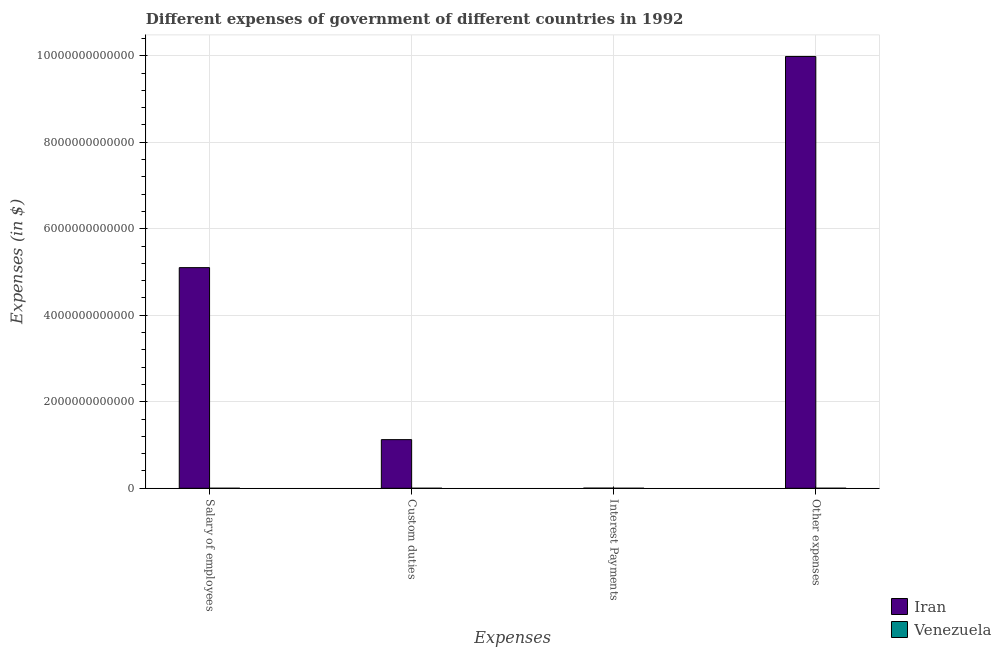How many groups of bars are there?
Your response must be concise. 4. What is the label of the 2nd group of bars from the left?
Your answer should be very brief. Custom duties. What is the amount spent on custom duties in Iran?
Provide a short and direct response. 1.12e+12. Across all countries, what is the maximum amount spent on other expenses?
Your answer should be very brief. 9.98e+12. Across all countries, what is the minimum amount spent on custom duties?
Your answer should be very brief. 8.47e+07. In which country was the amount spent on other expenses maximum?
Make the answer very short. Iran. In which country was the amount spent on interest payments minimum?
Provide a succinct answer. Venezuela. What is the total amount spent on interest payments in the graph?
Provide a succinct answer. 3.13e+09. What is the difference between the amount spent on other expenses in Venezuela and that in Iran?
Provide a short and direct response. -9.98e+12. What is the difference between the amount spent on custom duties in Venezuela and the amount spent on interest payments in Iran?
Make the answer very short. -2.92e+09. What is the average amount spent on custom duties per country?
Ensure brevity in your answer.  5.62e+11. What is the difference between the amount spent on other expenses and amount spent on custom duties in Iran?
Your answer should be compact. 8.86e+12. In how many countries, is the amount spent on other expenses greater than 7600000000000 $?
Provide a succinct answer. 1. What is the ratio of the amount spent on custom duties in Venezuela to that in Iran?
Your response must be concise. 7.528679413072477e-5. Is the amount spent on salary of employees in Iran less than that in Venezuela?
Provide a succinct answer. No. Is the difference between the amount spent on salary of employees in Venezuela and Iran greater than the difference between the amount spent on interest payments in Venezuela and Iran?
Offer a terse response. No. What is the difference between the highest and the second highest amount spent on other expenses?
Keep it short and to the point. 9.98e+12. What is the difference between the highest and the lowest amount spent on custom duties?
Make the answer very short. 1.12e+12. Is it the case that in every country, the sum of the amount spent on other expenses and amount spent on salary of employees is greater than the sum of amount spent on interest payments and amount spent on custom duties?
Give a very brief answer. No. What does the 2nd bar from the left in Custom duties represents?
Ensure brevity in your answer.  Venezuela. What does the 2nd bar from the right in Interest Payments represents?
Offer a very short reply. Iran. Is it the case that in every country, the sum of the amount spent on salary of employees and amount spent on custom duties is greater than the amount spent on interest payments?
Your answer should be compact. Yes. How many bars are there?
Offer a terse response. 8. Are all the bars in the graph horizontal?
Your answer should be compact. No. How many countries are there in the graph?
Offer a very short reply. 2. What is the difference between two consecutive major ticks on the Y-axis?
Your answer should be compact. 2.00e+12. Does the graph contain grids?
Provide a short and direct response. Yes. What is the title of the graph?
Make the answer very short. Different expenses of government of different countries in 1992. What is the label or title of the X-axis?
Your answer should be compact. Expenses. What is the label or title of the Y-axis?
Provide a short and direct response. Expenses (in $). What is the Expenses (in $) in Iran in Salary of employees?
Give a very brief answer. 5.10e+12. What is the Expenses (in $) in Venezuela in Salary of employees?
Ensure brevity in your answer.  2.16e+08. What is the Expenses (in $) in Iran in Custom duties?
Provide a short and direct response. 1.12e+12. What is the Expenses (in $) in Venezuela in Custom duties?
Your answer should be compact. 8.47e+07. What is the Expenses (in $) of Iran in Interest Payments?
Keep it short and to the point. 3.00e+09. What is the Expenses (in $) in Venezuela in Interest Payments?
Give a very brief answer. 1.34e+08. What is the Expenses (in $) in Iran in Other expenses?
Your answer should be compact. 9.98e+12. What is the Expenses (in $) in Venezuela in Other expenses?
Provide a succinct answer. 7.72e+08. Across all Expenses, what is the maximum Expenses (in $) in Iran?
Offer a terse response. 9.98e+12. Across all Expenses, what is the maximum Expenses (in $) of Venezuela?
Provide a short and direct response. 7.72e+08. Across all Expenses, what is the minimum Expenses (in $) of Iran?
Your answer should be compact. 3.00e+09. Across all Expenses, what is the minimum Expenses (in $) in Venezuela?
Offer a very short reply. 8.47e+07. What is the total Expenses (in $) of Iran in the graph?
Keep it short and to the point. 1.62e+13. What is the total Expenses (in $) in Venezuela in the graph?
Give a very brief answer. 1.21e+09. What is the difference between the Expenses (in $) in Iran in Salary of employees and that in Custom duties?
Your answer should be compact. 3.98e+12. What is the difference between the Expenses (in $) of Venezuela in Salary of employees and that in Custom duties?
Keep it short and to the point. 1.31e+08. What is the difference between the Expenses (in $) in Iran in Salary of employees and that in Interest Payments?
Ensure brevity in your answer.  5.10e+12. What is the difference between the Expenses (in $) of Venezuela in Salary of employees and that in Interest Payments?
Your response must be concise. 8.16e+07. What is the difference between the Expenses (in $) in Iran in Salary of employees and that in Other expenses?
Provide a succinct answer. -4.88e+12. What is the difference between the Expenses (in $) of Venezuela in Salary of employees and that in Other expenses?
Your answer should be compact. -5.56e+08. What is the difference between the Expenses (in $) in Iran in Custom duties and that in Interest Payments?
Provide a short and direct response. 1.12e+12. What is the difference between the Expenses (in $) in Venezuela in Custom duties and that in Interest Payments?
Offer a very short reply. -4.97e+07. What is the difference between the Expenses (in $) in Iran in Custom duties and that in Other expenses?
Ensure brevity in your answer.  -8.86e+12. What is the difference between the Expenses (in $) of Venezuela in Custom duties and that in Other expenses?
Offer a terse response. -6.88e+08. What is the difference between the Expenses (in $) of Iran in Interest Payments and that in Other expenses?
Provide a succinct answer. -9.98e+12. What is the difference between the Expenses (in $) of Venezuela in Interest Payments and that in Other expenses?
Provide a short and direct response. -6.38e+08. What is the difference between the Expenses (in $) in Iran in Salary of employees and the Expenses (in $) in Venezuela in Custom duties?
Give a very brief answer. 5.10e+12. What is the difference between the Expenses (in $) in Iran in Salary of employees and the Expenses (in $) in Venezuela in Interest Payments?
Your answer should be compact. 5.10e+12. What is the difference between the Expenses (in $) of Iran in Salary of employees and the Expenses (in $) of Venezuela in Other expenses?
Provide a succinct answer. 5.10e+12. What is the difference between the Expenses (in $) in Iran in Custom duties and the Expenses (in $) in Venezuela in Interest Payments?
Ensure brevity in your answer.  1.12e+12. What is the difference between the Expenses (in $) in Iran in Custom duties and the Expenses (in $) in Venezuela in Other expenses?
Provide a succinct answer. 1.12e+12. What is the difference between the Expenses (in $) in Iran in Interest Payments and the Expenses (in $) in Venezuela in Other expenses?
Give a very brief answer. 2.23e+09. What is the average Expenses (in $) in Iran per Expenses?
Your response must be concise. 4.05e+12. What is the average Expenses (in $) in Venezuela per Expenses?
Offer a very short reply. 3.02e+08. What is the difference between the Expenses (in $) in Iran and Expenses (in $) in Venezuela in Salary of employees?
Ensure brevity in your answer.  5.10e+12. What is the difference between the Expenses (in $) of Iran and Expenses (in $) of Venezuela in Custom duties?
Offer a terse response. 1.12e+12. What is the difference between the Expenses (in $) in Iran and Expenses (in $) in Venezuela in Interest Payments?
Your answer should be compact. 2.87e+09. What is the difference between the Expenses (in $) in Iran and Expenses (in $) in Venezuela in Other expenses?
Provide a short and direct response. 9.98e+12. What is the ratio of the Expenses (in $) in Iran in Salary of employees to that in Custom duties?
Make the answer very short. 4.54. What is the ratio of the Expenses (in $) in Venezuela in Salary of employees to that in Custom duties?
Your response must be concise. 2.55. What is the ratio of the Expenses (in $) of Iran in Salary of employees to that in Interest Payments?
Ensure brevity in your answer.  1700.33. What is the ratio of the Expenses (in $) in Venezuela in Salary of employees to that in Interest Payments?
Ensure brevity in your answer.  1.61. What is the ratio of the Expenses (in $) of Iran in Salary of employees to that in Other expenses?
Make the answer very short. 0.51. What is the ratio of the Expenses (in $) of Venezuela in Salary of employees to that in Other expenses?
Provide a short and direct response. 0.28. What is the ratio of the Expenses (in $) of Iran in Custom duties to that in Interest Payments?
Offer a very short reply. 374.83. What is the ratio of the Expenses (in $) in Venezuela in Custom duties to that in Interest Payments?
Keep it short and to the point. 0.63. What is the ratio of the Expenses (in $) in Iran in Custom duties to that in Other expenses?
Offer a very short reply. 0.11. What is the ratio of the Expenses (in $) in Venezuela in Custom duties to that in Other expenses?
Your answer should be compact. 0.11. What is the ratio of the Expenses (in $) of Venezuela in Interest Payments to that in Other expenses?
Offer a very short reply. 0.17. What is the difference between the highest and the second highest Expenses (in $) of Iran?
Your answer should be compact. 4.88e+12. What is the difference between the highest and the second highest Expenses (in $) of Venezuela?
Your response must be concise. 5.56e+08. What is the difference between the highest and the lowest Expenses (in $) of Iran?
Give a very brief answer. 9.98e+12. What is the difference between the highest and the lowest Expenses (in $) in Venezuela?
Offer a very short reply. 6.88e+08. 